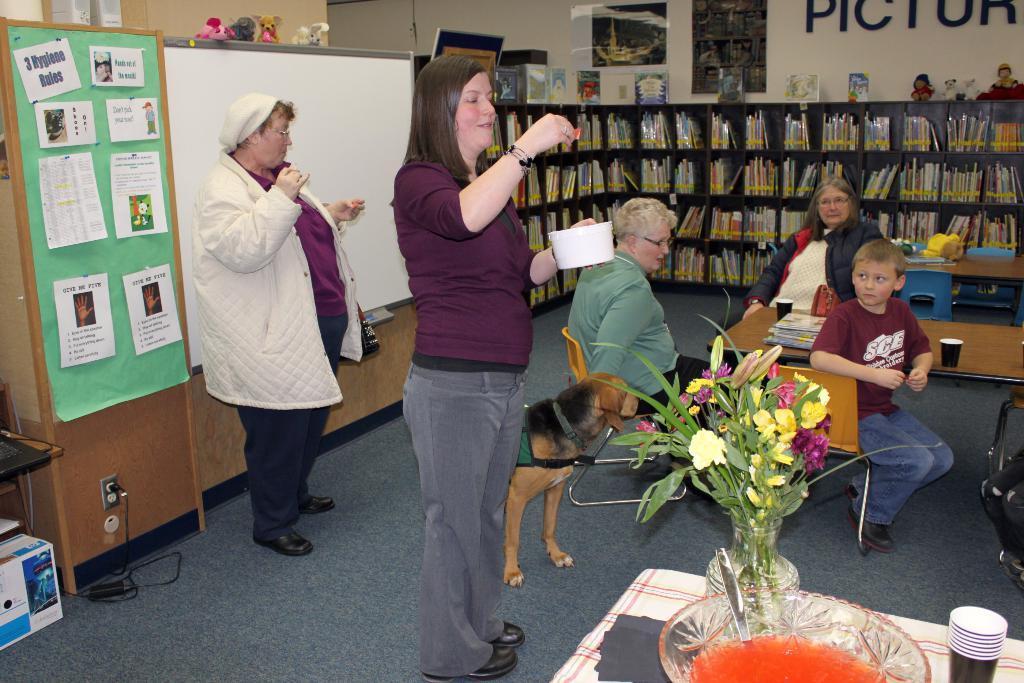Could you give a brief overview of what you see in this image? In this image we can see few people in which some of them are sitting and some of them are standing, there we can see a one person holding a bowl and an object, there we can see two tables in which we can see a flower pot, a bowl with some fluid, a spoon and some cups on one table, on the other table, we can see few books and two glasses, there we can see a another table with some objects on it, few chairs, few books in the racks on the shelf and some frames placed over the shelf, two posters attached and a name to the wall, a shelf with some papers attached to it, a screen with some toys on it 